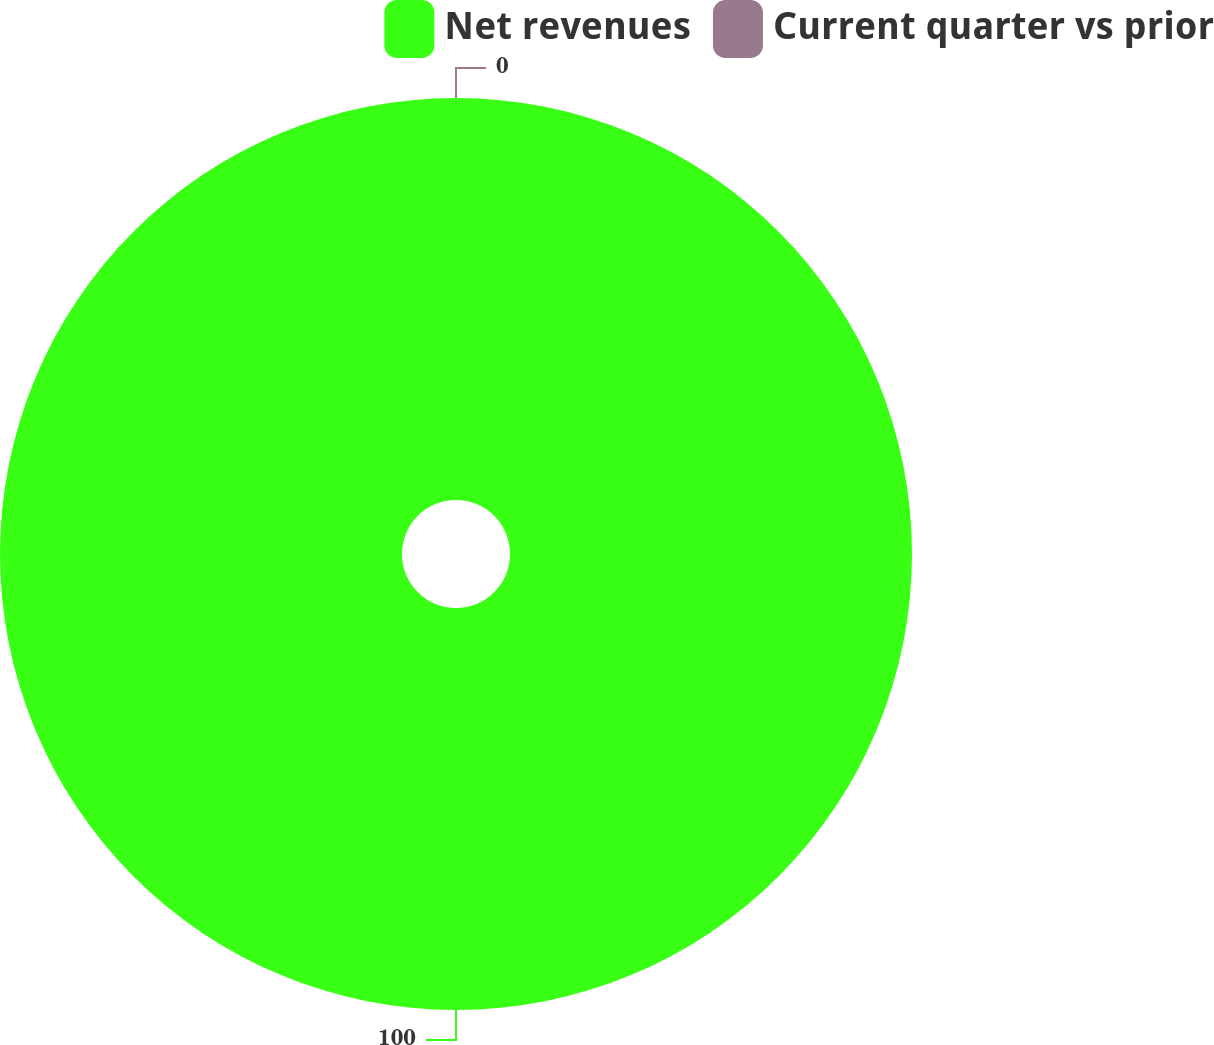<chart> <loc_0><loc_0><loc_500><loc_500><pie_chart><fcel>Net revenues<fcel>Current quarter vs prior<nl><fcel>100.0%<fcel>0.0%<nl></chart> 